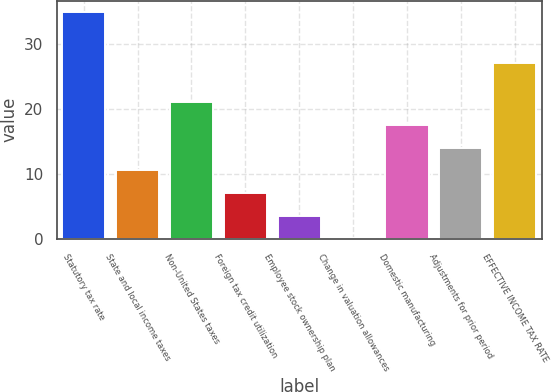Convert chart. <chart><loc_0><loc_0><loc_500><loc_500><bar_chart><fcel>Statutory tax rate<fcel>State and local income taxes<fcel>Non-United States taxes<fcel>Foreign tax credit utilization<fcel>Employee stock ownership plan<fcel>Change in valuation allowances<fcel>Domestic manufacturing<fcel>Adjustments for prior period<fcel>EFFECTIVE INCOME TAX RATE<nl><fcel>35<fcel>10.57<fcel>21.04<fcel>7.08<fcel>3.59<fcel>0.1<fcel>17.55<fcel>14.06<fcel>27.1<nl></chart> 